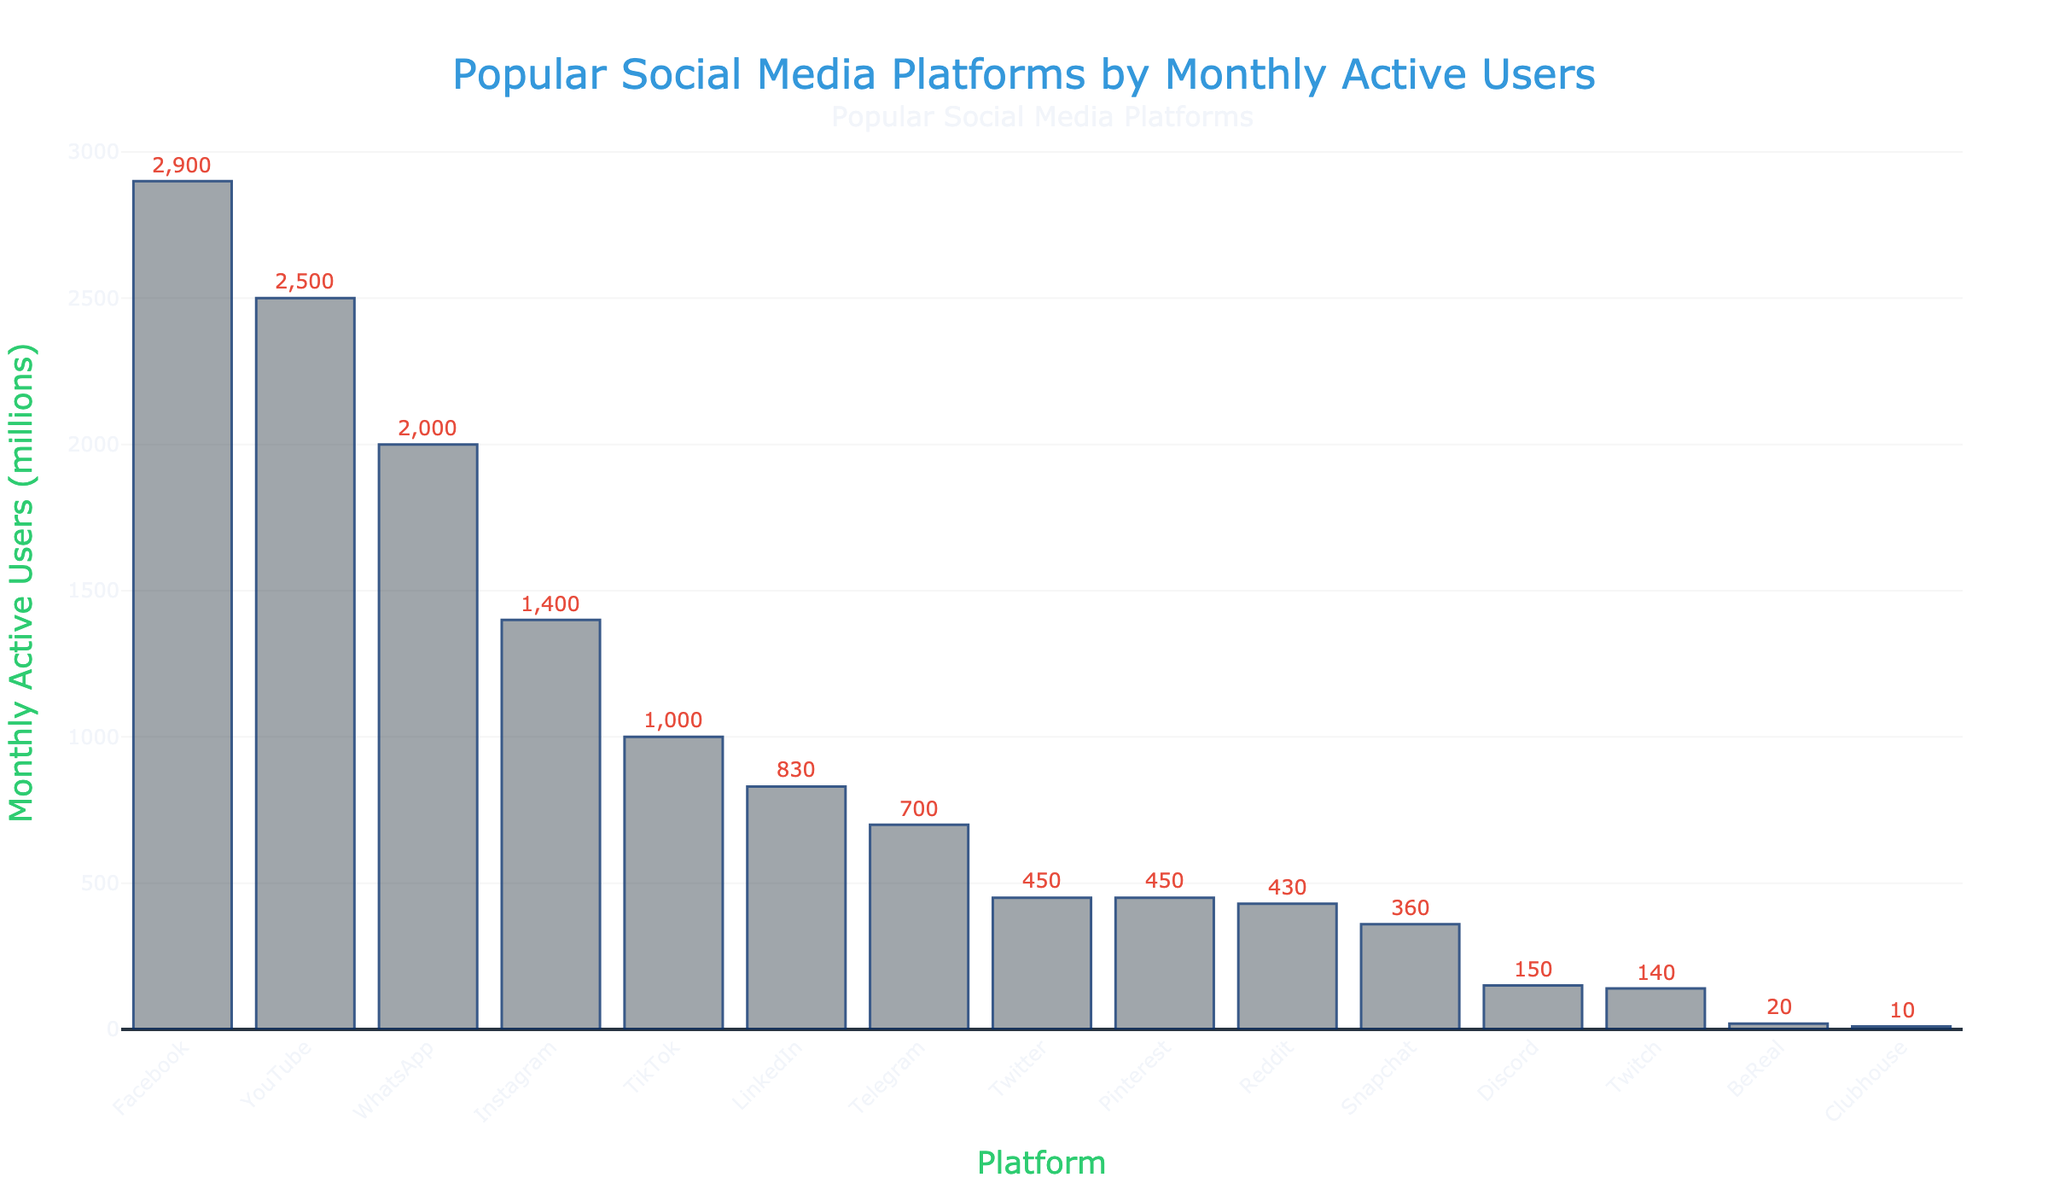What are the top three platforms by monthly active users? The top three platforms are those with the highest bars. According to the figure, they are Facebook (2900 million), YouTube (2500 million), and WhatsApp (2000 million).
Answer: Facebook, YouTube, WhatsApp Which platform has the lowest number of monthly active users? The platform with the smallest bar represents the lowest number of monthly active users. Clubhouse has the lowest number with 10 million users.
Answer: Clubhouse What is the difference in monthly active users between Twitter and Instagram? Find the heights of the Twitter and Instagram bars. Instagram has 1400 million users and Twitter has 450 million. The difference is 1400 - 450 = 950 million users.
Answer: 950 million How many platforms have over 1000 million monthly active users? Count the platforms with bars reaching higher than 1000 million users. They are Facebook, YouTube, WhatsApp, and Instagram, making a total of 4 platforms.
Answer: 4 platforms Compare the number of monthly active users between LinkedIn and Telegram. Which one has more users? Compare the heights of the LinkedIn and Telegram bars. LinkedIn has 830 million users, and Telegram has 700 million users. LinkedIn has more users.
Answer: LinkedIn What is the average number of monthly active users among the top five platforms? The top five platforms are: Facebook (2900 million), YouTube (2500 million), WhatsApp (2000 million), Instagram (1400 million), and TikTok (1000 million). Sum these values: 2900 + 2500 + 2000 + 1400 + 1000 = 9800. The average is 9800 / 5 = 1960 million users.
Answer: 1960 million Are there any platforms with the same number of monthly active users? Look for bars of the same height. Twitter and Pinterest both have 450 million users.
Answer: Yes, Twitter and Pinterest Rank the platforms based on the number of monthly active users from highest to lowest. List the platforms from tallest bar to shortest bar: Facebook, YouTube, WhatsApp, Instagram, TikTok, Telegram, LinkedIn, Snapchat, Reddit, Twitter and Pinterest, Discord, Twitch, BeReal, and Clubhouse.
Answer: Facebook, YouTube, WhatsApp, Instagram, TikTok, Telegram, LinkedIn, Snapchat, Reddit, Twitter, Pinterest, Discord, Twitch, BeReal, Clubhouse What is the sum of monthly active users for Discord, Twitch, and Clubhouse? Find the heights of the bars for Discord (150 million), Twitch (140 million), and Clubhouse (10 million). Sum them: 150 + 140 + 10 = 300 million users.
Answer: 300 million Which platform among Snapchat, Reddit, and Twitter has the highest number of monthly active users? Compare the heights of the Snapchat, Reddit, and Twitter bars. Snapchat has 360 million users, Reddit has 430 million, and Twitter has 450 million. Twitter has the highest number of users among the three.
Answer: Twitter 